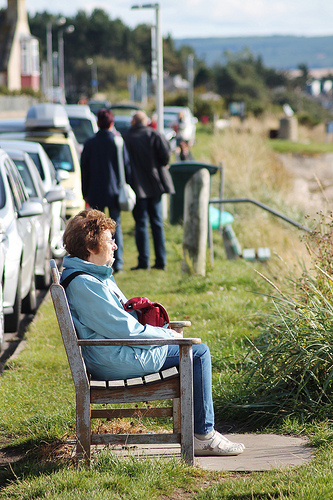<image>
Is the woman in front of the person? Yes. The woman is positioned in front of the person, appearing closer to the camera viewpoint. 